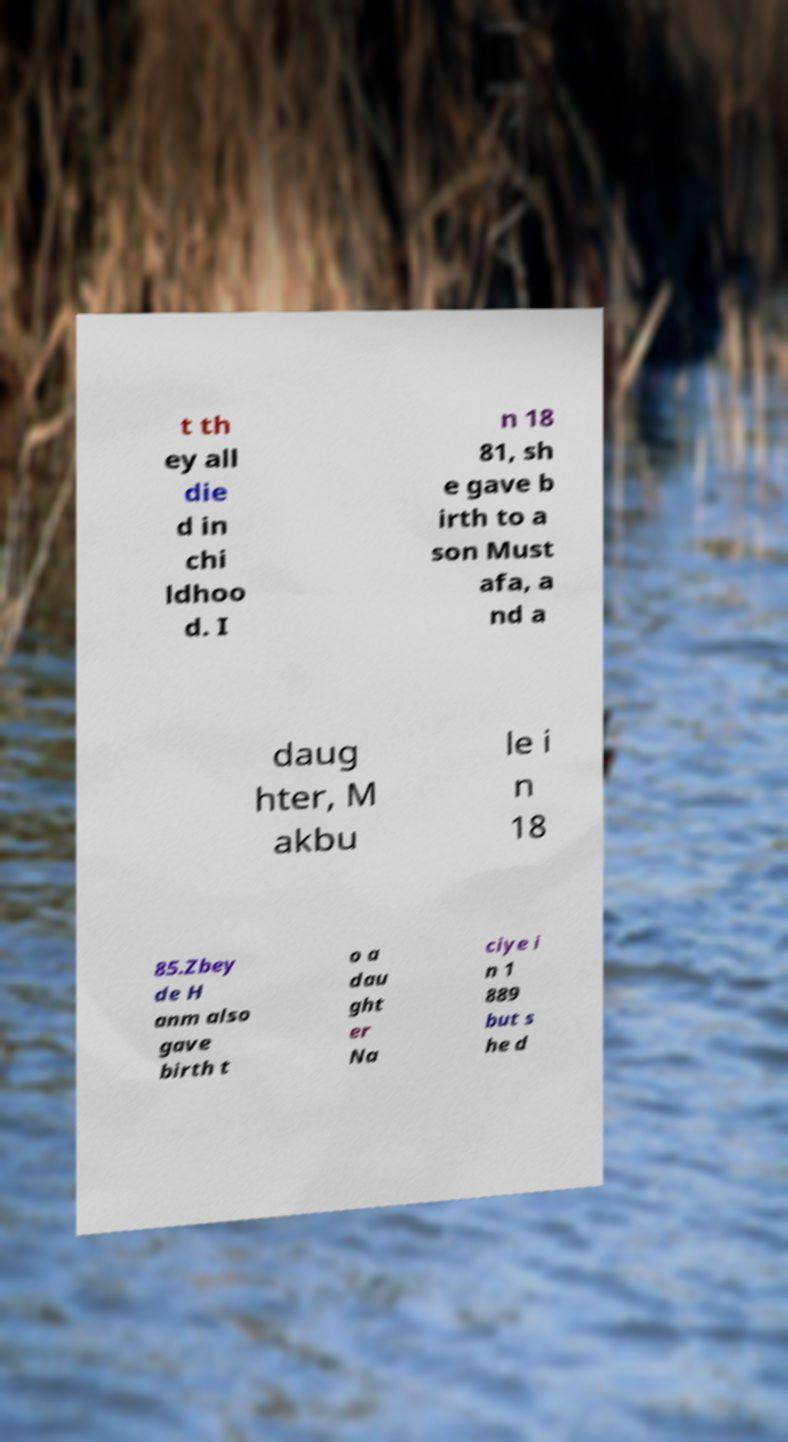For documentation purposes, I need the text within this image transcribed. Could you provide that? t th ey all die d in chi ldhoo d. I n 18 81, sh e gave b irth to a son Must afa, a nd a daug hter, M akbu le i n 18 85.Zbey de H anm also gave birth t o a dau ght er Na ciye i n 1 889 but s he d 